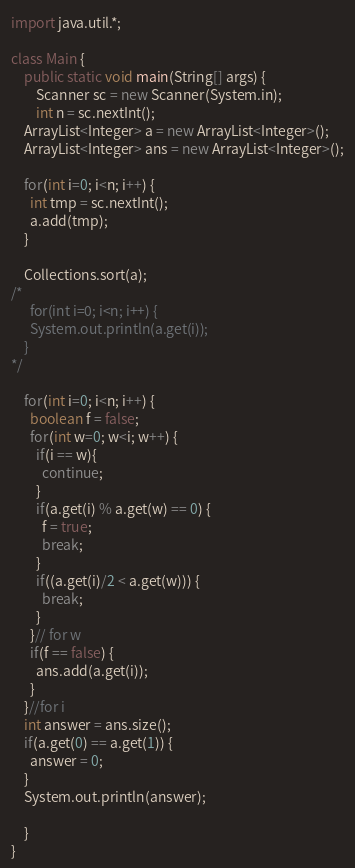<code> <loc_0><loc_0><loc_500><loc_500><_Java_>import java.util.*;

class Main {
	public static void main(String[] args) {
		Scanner sc = new Scanner(System.in);
		int n = sc.nextInt();
    ArrayList<Integer> a = new ArrayList<Integer>();
    ArrayList<Integer> ans = new ArrayList<Integer>();

    for(int i=0; i<n; i++) {
      int tmp = sc.nextInt();
      a.add(tmp);
    }

    Collections.sort(a);
/*
      for(int i=0; i<n; i++) {
      System.out.println(a.get(i));
    }
*/

    for(int i=0; i<n; i++) {
      boolean f = false;
      for(int w=0; w<i; w++) {
        if(i == w){
          continue;
        }
        if(a.get(i) % a.get(w) == 0) {
          f = true;
          break;
        }
        if((a.get(i)/2 < a.get(w))) {
          break;
        }
      }// for w
      if(f == false) {
        ans.add(a.get(i));
      }
    }//for i
    int answer = ans.size();
    if(a.get(0) == a.get(1)) {
      answer = 0;
    }
    System.out.println(answer);

	}
}
</code> 